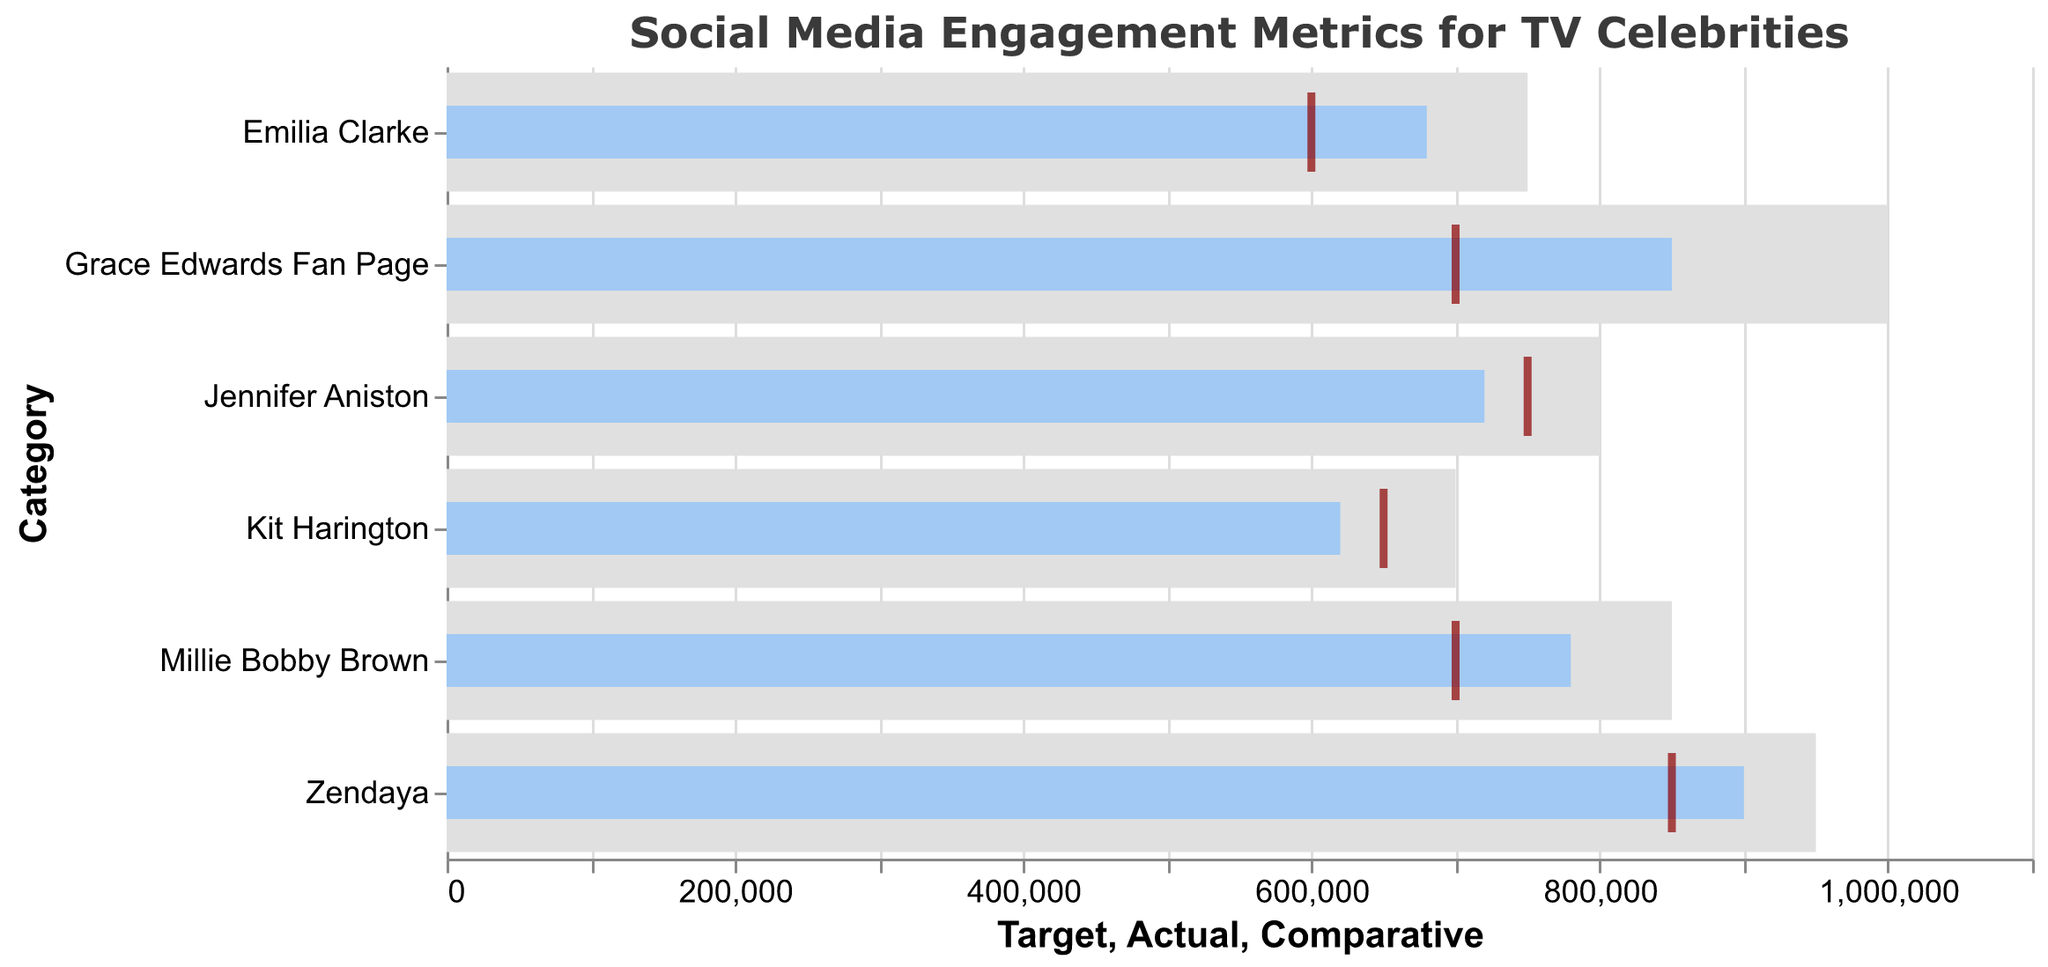What is the title of the figure? The title is displayed at the top of the figure and provides a clear description of what the chart is showing.
Answer: Social Media Engagement Metrics for TV Celebrities How many categories of TV celebrities are included in the figure? Count the different bars, as each bar represents a category of TV celebrities.
Answer: 6 What are the actual engagement numbers for Grace Edwards Fan Page and Zendaya? Refer to the blue bars labeled "Grace Edwards Fan Page" and "Zendaya" and read the values on the x-axis.
Answer: 850,000 and 900,000 Which category has the highest actual engagement metric? Compare the height of the blue bars for all categories and identify the tallest one.
Answer: Zendaya Is the actual engagement for Grace Edwards Fan Page above or below the target? Compare the blue bar (Actual) to the gray bar (Target) for "Grace Edwards Fan Page."
Answer: Below What is the difference between the actual and target engagement for Jennifer Aniston? Subtract Jennifer Aniston's actual engagement from her target engagement: 800,000 - 720,000.
Answer: 80,000 How does the comparative engagement for Emilia Clarke compare to her actual engagement? Observe the tick mark (Comparative) and the blue bar (Actual) for Emilia Clarke and note whether the tick is to the left (less) or right (more) of the bar.
Answer: Lower What is the average target engagement of the categories? Sum all the target engagements (1,000,000 + 800,000 + 750,000 + 700,000 + 850,000 + 950,000) and divide by the number of categories (6).
Answer: 841,667 List the categories where the actual engagement exceeds the comparative engagement. Check which blue bars (Actual) are to the right of their respective tick marks (Comparative) across all categories.
Answer: Grace Edwards Fan Page, Millie Bobby Brown, Zendaya How much more is Zendaya's actual engagement compared to Kit Harington's actual engagement? Subtract Kit Harington's actual engagement from Zendaya's actual engagement: 900,000 - 620,000.
Answer: 280,000 